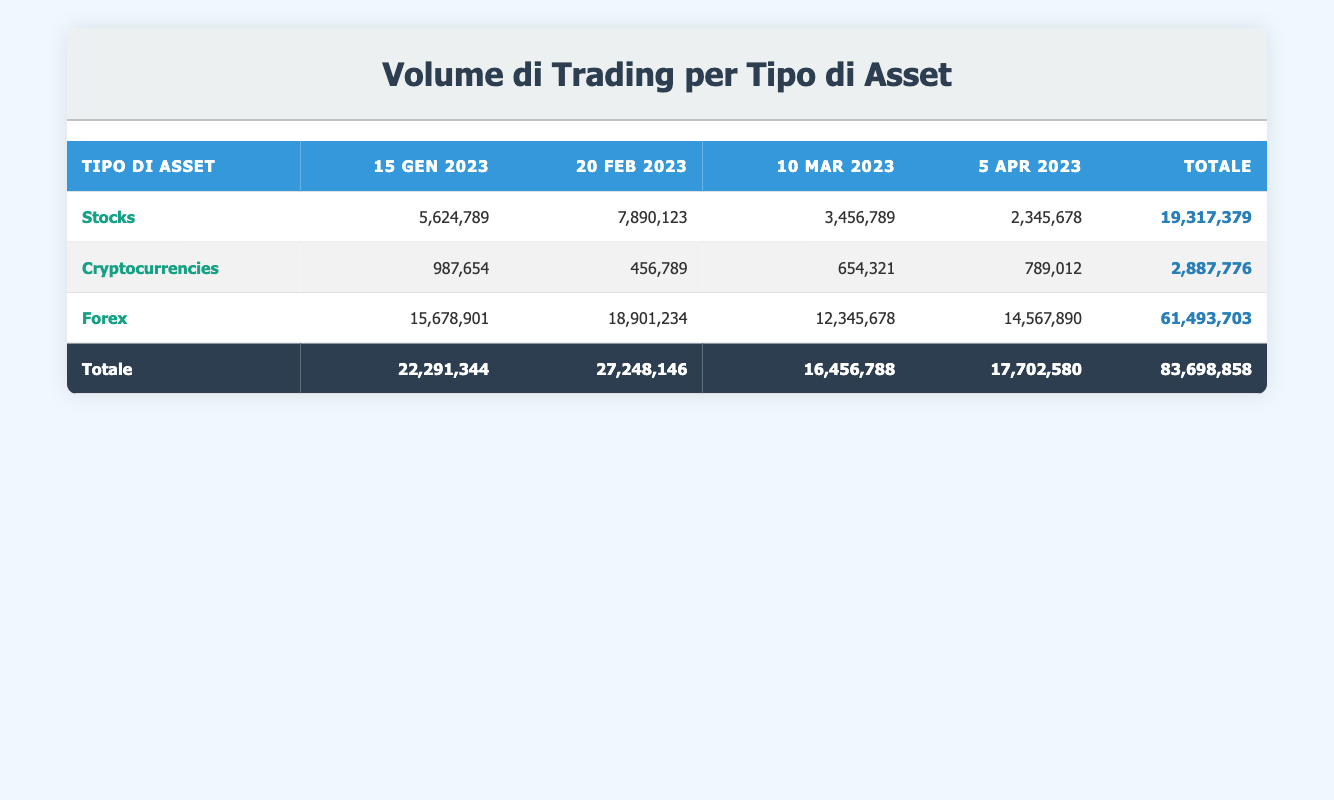Qual è il volume di trading totale per le azioni il 15 gennaio 2023? Il volume di trading per le azioni il 15 gennaio 2023 è 5,624,789, quindi questo è il dato che stiamo cercando.
Answer: 5,624,789 Qual è la somma del volume di trading totale per le criptovalute e le azioni il 20 febbraio 2023? Il volume di trading per le criptovalute il 20 febbraio 2023 è 456,789 e per le azioni è 7,890,123. Sommiamo i due volumi: 456,789 + 7,890,123 = 8,346,912.
Answer: 8,346,912 Il volume di trading per le criptovalute è superiore a quello delle azioni il 5 aprile 2023? Il volume di trading per le criptovalute il 5 aprile 2023 è 789,012, mentre per le azioni è 2,345,678.  Isolatamente, 789,012 è inferiore a 2,345,678, quindi la risposta è no.
Answer: No Qual è il volume di trading totale per il Forex tra il 15 gennaio e il 5 aprile 2023? Sommiamo il volume di trading per il Forex in ciascuna data: il 15 gennaio è 15,678,901, il 20 febbraio è 18,901,234, il 10 marzo è 12,345,678 e il 5 aprile è 14,567,890. Somma totale: 15,678,901 + 18,901,234 + 12,345,678 + 14,567,890 = 61,493,703.
Answer: 61,493,703 Quante volte il volume di trading delle criptovalute il 10 marzo 2023 supera quello del 15 gennaio 2023? Il volume delle criptovalute il 10 marzo è 654,321 e quello del 15 gennaio è 987,654. Calcoliamo il rapporto: 654,321 / 987,654 circa 0.66. Questo significa che il volume del 10 marzo è 66% di quello del 15 gennaio, quindi non supera mai.
Answer: 0 vezes 